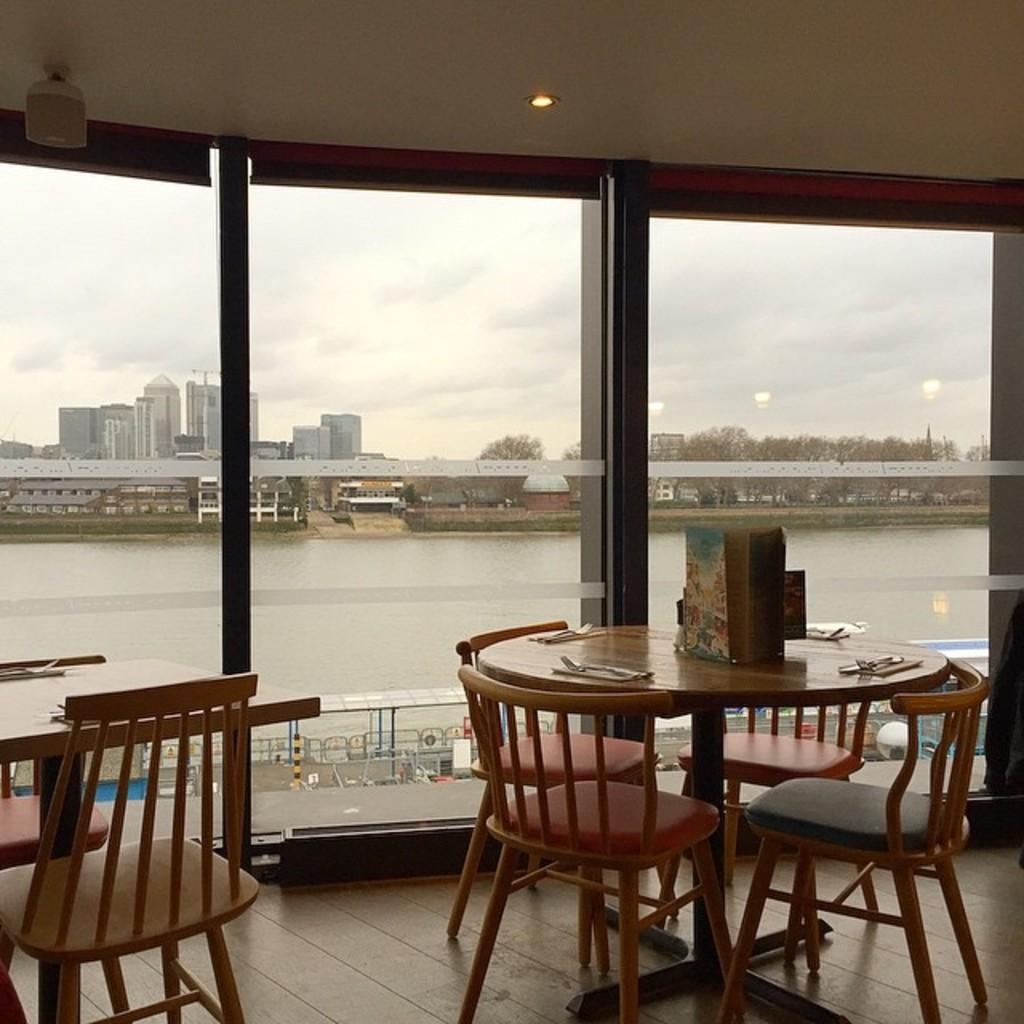What type of furniture is present in the image? There are tables and chairs in the image. How are the tables arranged? The chairs are arranged around the tables. What can be seen through the glass doors in the background? The glass doors lead to a view of a lake. What other elements can be seen in the background? Trees, buildings, and the sky are visible in the background. What type of advertisement is displayed on the tables in the image? There is no advertisement present on the tables in the image. What type of wool can be seen on the chairs in the image? There is no wool visible on the chairs in the image. 